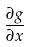Convert formula to latex. <formula><loc_0><loc_0><loc_500><loc_500>\frac { \partial g } { \partial x }</formula> 